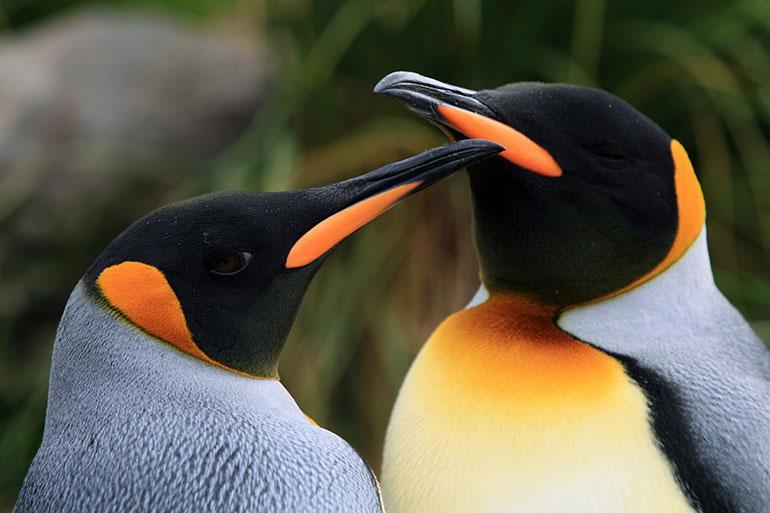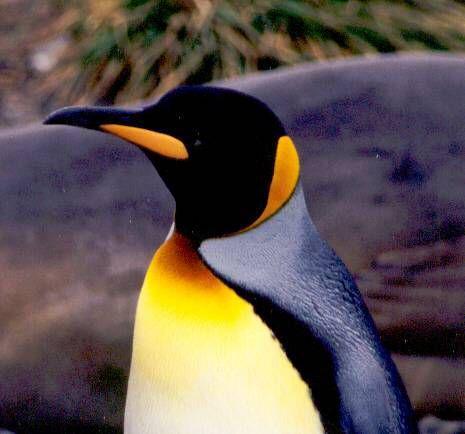The first image is the image on the left, the second image is the image on the right. Examine the images to the left and right. Is the description "In one image there is a pair of penguins nuzzling each others' beak." accurate? Answer yes or no. Yes. 